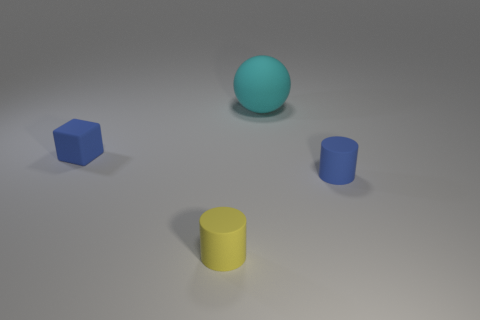What number of other objects are there of the same size as the cyan rubber thing?
Keep it short and to the point. 0. There is a matte thing that is behind the small rubber object that is to the left of the yellow matte cylinder; what size is it?
Provide a succinct answer. Large. Are there any small cylinders of the same color as the small cube?
Your answer should be very brief. Yes. There is a small object to the right of the small yellow matte thing; does it have the same color as the small matte object behind the tiny blue cylinder?
Offer a very short reply. Yes. What shape is the big cyan matte object?
Your response must be concise. Sphere. What number of small yellow rubber objects are in front of the big object?
Keep it short and to the point. 1. What number of blue cylinders are made of the same material as the yellow thing?
Your answer should be compact. 1. Is the material of the small cylinder that is right of the large ball the same as the big ball?
Your answer should be compact. Yes. Is there a blue rubber cylinder?
Keep it short and to the point. Yes. There is a object that is both to the right of the yellow matte object and behind the small blue cylinder; what size is it?
Give a very brief answer. Large. 